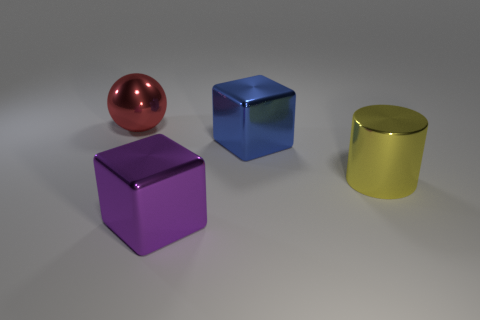Is the number of objects that are on the left side of the large yellow metal cylinder greater than the number of yellow objects?
Your answer should be compact. Yes. What material is the large thing left of the block that is in front of the big blue cube behind the purple block?
Ensure brevity in your answer.  Metal. Is the number of big blue shiny blocks greater than the number of large cubes?
Provide a succinct answer. No. What is the material of the big purple block?
Provide a succinct answer. Metal. What number of purple objects are the same size as the sphere?
Make the answer very short. 1. Are there any large yellow objects that have the same shape as the purple shiny thing?
Offer a terse response. No. The metallic ball that is the same size as the purple object is what color?
Your answer should be very brief. Red. What is the color of the shiny thing to the left of the thing that is in front of the yellow object?
Provide a short and direct response. Red. There is a large metallic thing that is on the left side of the metal block in front of the large block that is on the right side of the purple cube; what shape is it?
Provide a short and direct response. Sphere. How many blocks are on the left side of the metal block that is in front of the big blue object?
Your response must be concise. 0. 